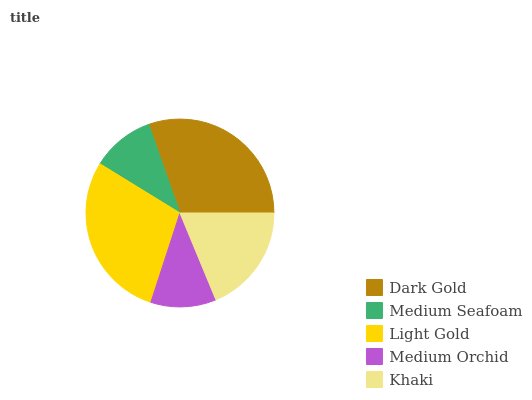Is Medium Seafoam the minimum?
Answer yes or no. Yes. Is Dark Gold the maximum?
Answer yes or no. Yes. Is Light Gold the minimum?
Answer yes or no. No. Is Light Gold the maximum?
Answer yes or no. No. Is Light Gold greater than Medium Seafoam?
Answer yes or no. Yes. Is Medium Seafoam less than Light Gold?
Answer yes or no. Yes. Is Medium Seafoam greater than Light Gold?
Answer yes or no. No. Is Light Gold less than Medium Seafoam?
Answer yes or no. No. Is Khaki the high median?
Answer yes or no. Yes. Is Khaki the low median?
Answer yes or no. Yes. Is Light Gold the high median?
Answer yes or no. No. Is Dark Gold the low median?
Answer yes or no. No. 